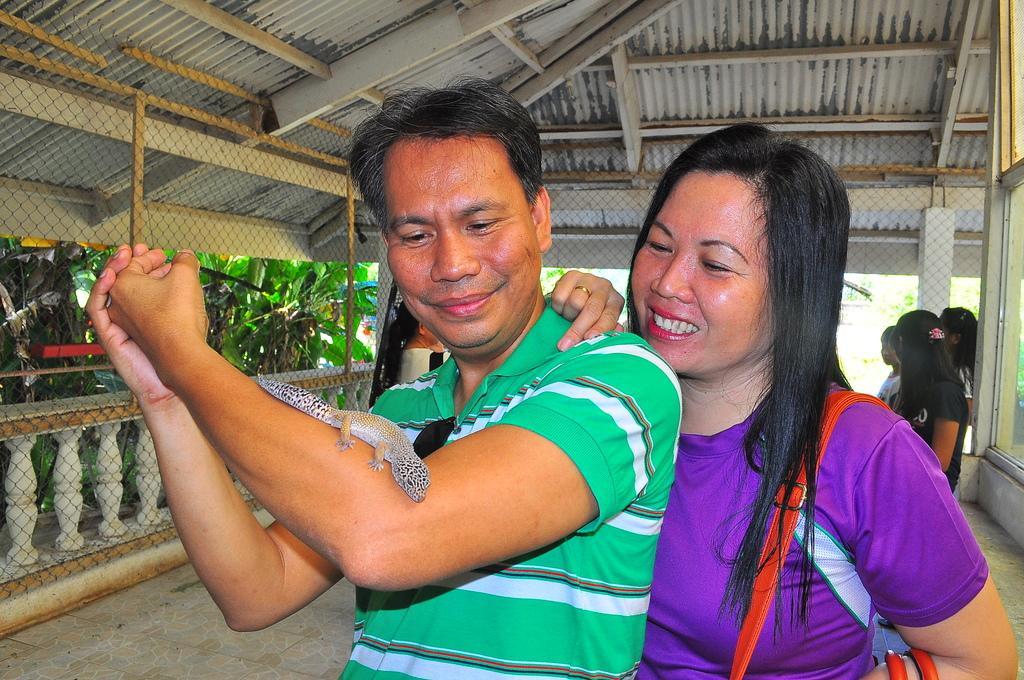In one or two sentences, can you explain what this image depicts? In this image I can see a person wearing green and white colored t shirt and a woman wearing violet colored t shirt are standing and I can see a reptile on the person's hand. In the background I can see the fencing, few persons standing, the ceiling and few trees which are green in color. 